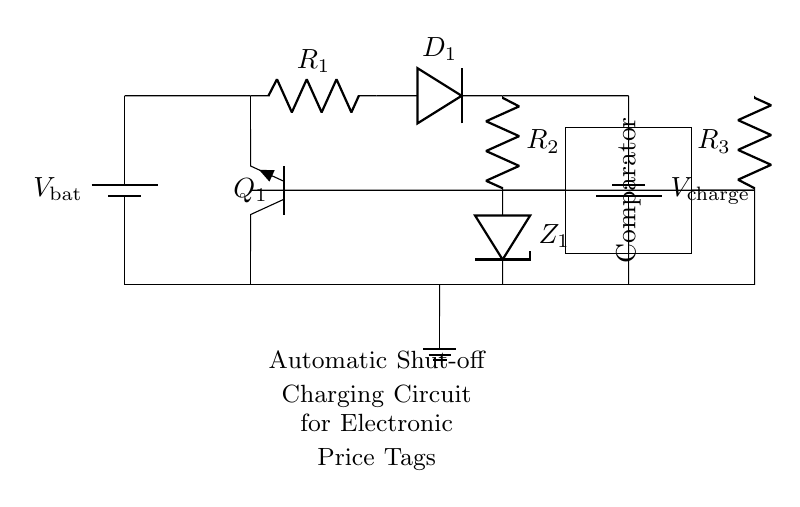what type of transistor is used in this circuit? The circuit diagram indicates the use of a "Tnpn" transistor, which refers to a type of NPN bipolar junction transistor. The notation suggests that it is designed for switching and amplification purposes.
Answer: NPN what components are used for charging the battery? The components involved in charging the battery include a battery (noted as $V_\text{charge}$), a resistor ($R_1$), and a diode ($D_1$). These components work together to manage the flow of current to the battery during the charging process.
Answer: Battery, Resistor, Diode how many resistors are present in the circuit? The circuit shows three resistors labeled as $R_1$, $R_2$, and $R_3$. Each plays a role in controlling the current flow and voltage levels within the circuit.
Answer: Three what is the purpose of the comparator in the circuit? The comparator's role is to compare the voltage levels from the charging circuit and the battery voltage to determine whether the battery requires charging or if it should be shut off to prevent overcharging. This adds an automatic shutdown feature to the charging process.
Answer: Voltage regulation what happens to the circuit if the battery is fully charged? When the battery reaches its full charge level, the comparator will detect this condition and shut off the charging current by controlling the transistor’s operation, thereby preventing any further charging. This automatic shutdown is crucial for battery safety and longevity.
Answer: Charging stops 